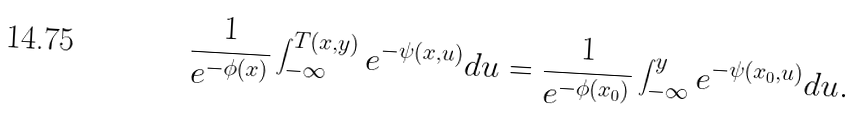Convert formula to latex. <formula><loc_0><loc_0><loc_500><loc_500>\frac { 1 } { e ^ { - \phi ( x ) } } \int _ { - \infty } ^ { T ( x , y ) } e ^ { - \psi ( x , u ) } d u = \frac { 1 } { e ^ { - \phi ( x _ { 0 } ) } } \int _ { - \infty } ^ { y } e ^ { - \psi ( x _ { 0 } , u ) } d u .</formula> 